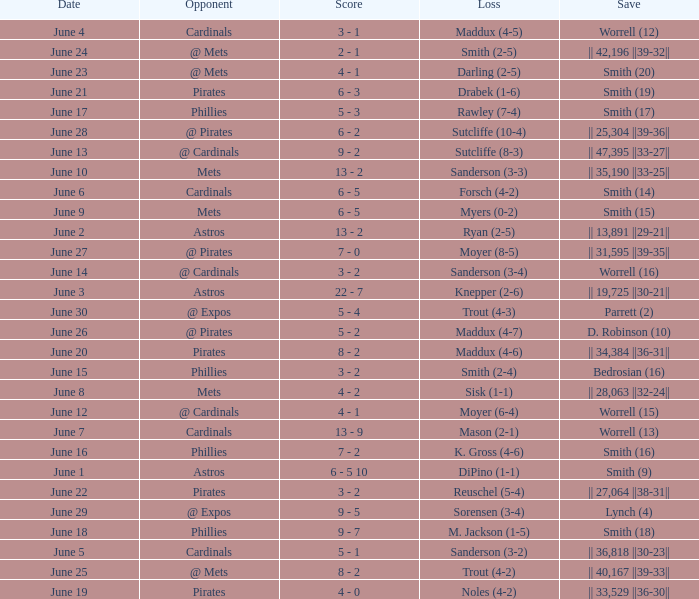What is the loss for the game against @ expos, with a save of parrett (2)? Trout (4-3). 